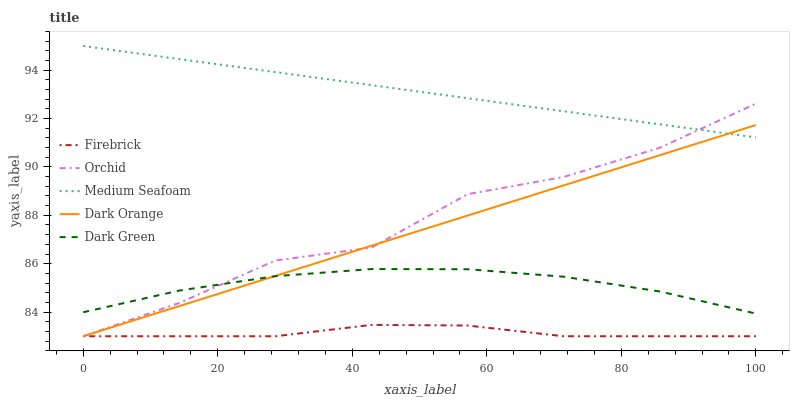Does Firebrick have the minimum area under the curve?
Answer yes or no. Yes. Does Medium Seafoam have the maximum area under the curve?
Answer yes or no. Yes. Does Dark Green have the minimum area under the curve?
Answer yes or no. No. Does Dark Green have the maximum area under the curve?
Answer yes or no. No. Is Dark Orange the smoothest?
Answer yes or no. Yes. Is Orchid the roughest?
Answer yes or no. Yes. Is Firebrick the smoothest?
Answer yes or no. No. Is Firebrick the roughest?
Answer yes or no. No. Does Dark Orange have the lowest value?
Answer yes or no. Yes. Does Dark Green have the lowest value?
Answer yes or no. No. Does Medium Seafoam have the highest value?
Answer yes or no. Yes. Does Dark Green have the highest value?
Answer yes or no. No. Is Dark Green less than Medium Seafoam?
Answer yes or no. Yes. Is Medium Seafoam greater than Dark Green?
Answer yes or no. Yes. Does Medium Seafoam intersect Dark Orange?
Answer yes or no. Yes. Is Medium Seafoam less than Dark Orange?
Answer yes or no. No. Is Medium Seafoam greater than Dark Orange?
Answer yes or no. No. Does Dark Green intersect Medium Seafoam?
Answer yes or no. No. 